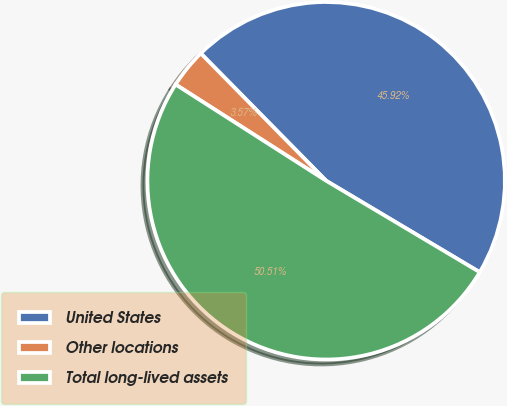<chart> <loc_0><loc_0><loc_500><loc_500><pie_chart><fcel>United States<fcel>Other locations<fcel>Total long-lived assets<nl><fcel>45.92%<fcel>3.57%<fcel>50.51%<nl></chart> 